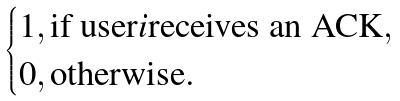Convert formula to latex. <formula><loc_0><loc_0><loc_500><loc_500>\begin{cases} 1 , \text {if user} i \text {receives an ACK} , \\ 0 , \text {otherwise} . \end{cases}</formula> 